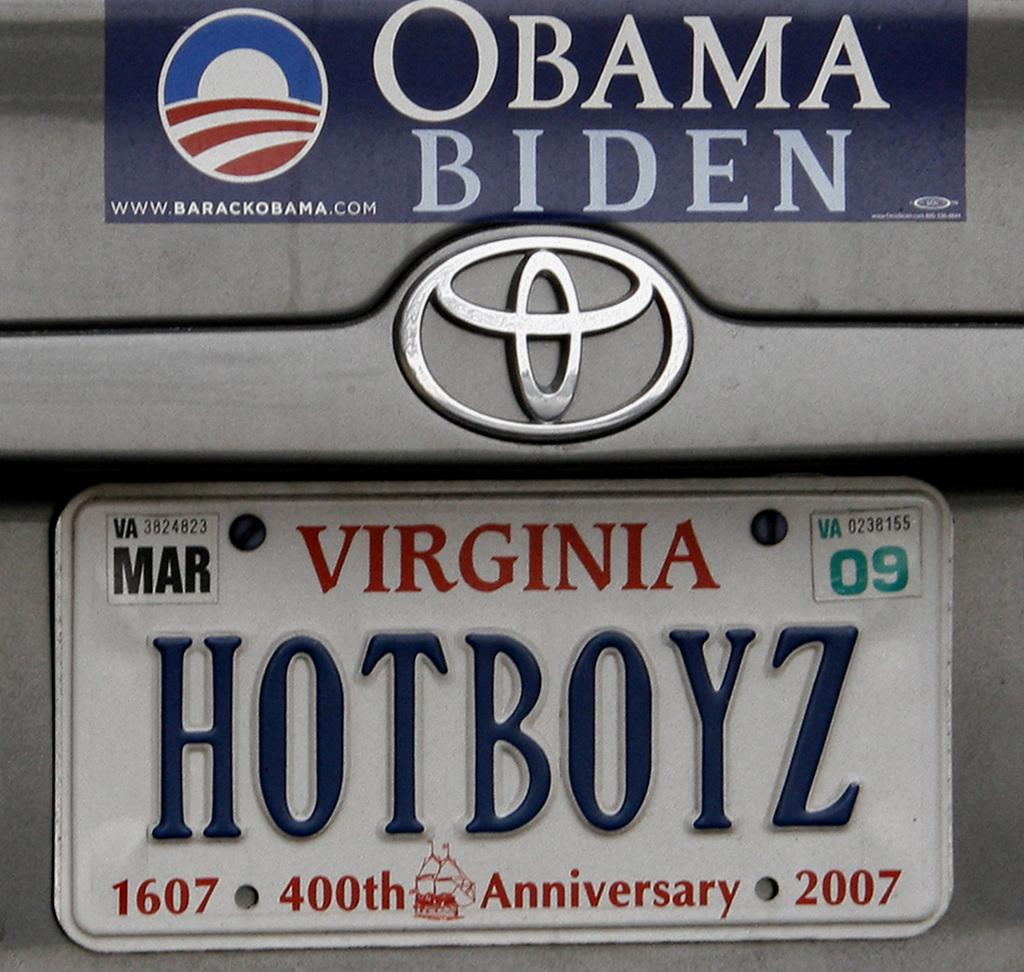<image>
Provide a brief description of the given image. Virginia car plate on the bottom of Obama Biden sticker. 